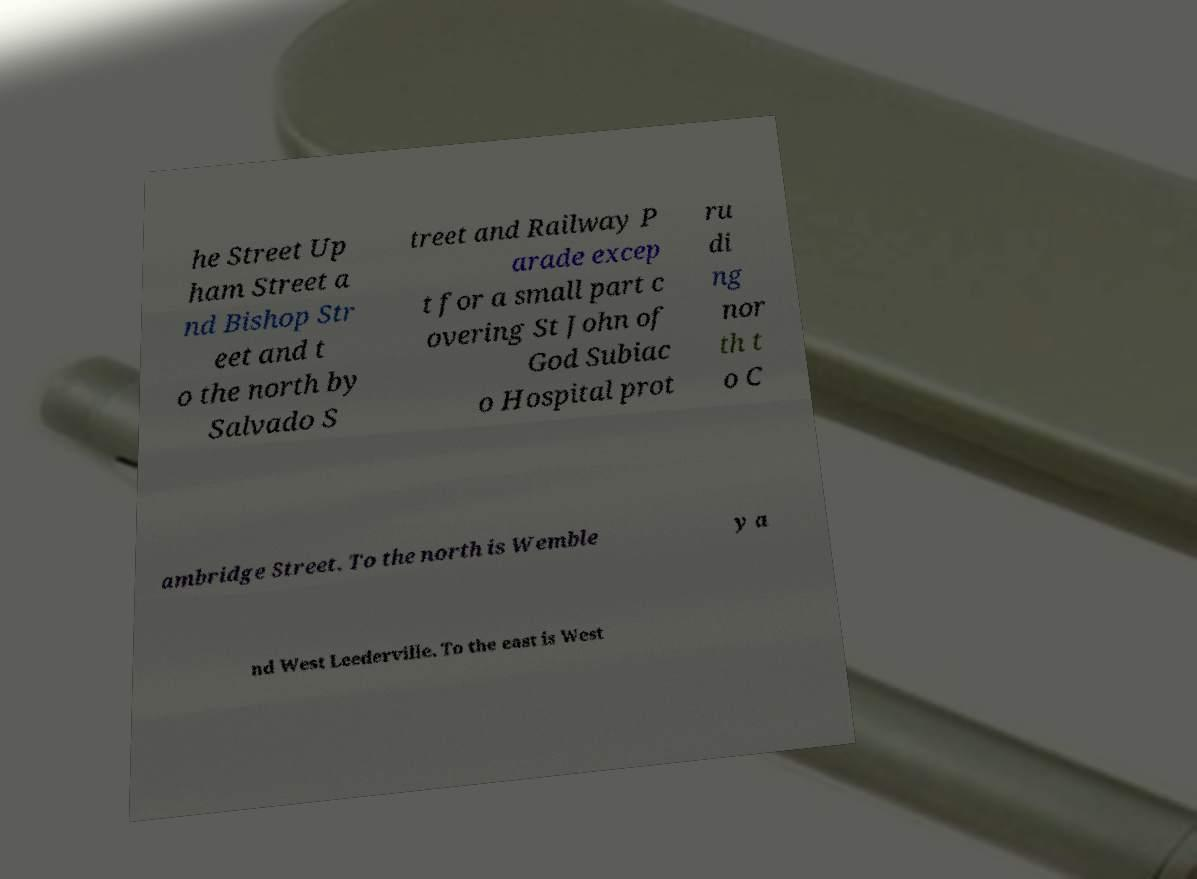What messages or text are displayed in this image? I need them in a readable, typed format. he Street Up ham Street a nd Bishop Str eet and t o the north by Salvado S treet and Railway P arade excep t for a small part c overing St John of God Subiac o Hospital prot ru di ng nor th t o C ambridge Street. To the north is Wemble y a nd West Leederville. To the east is West 